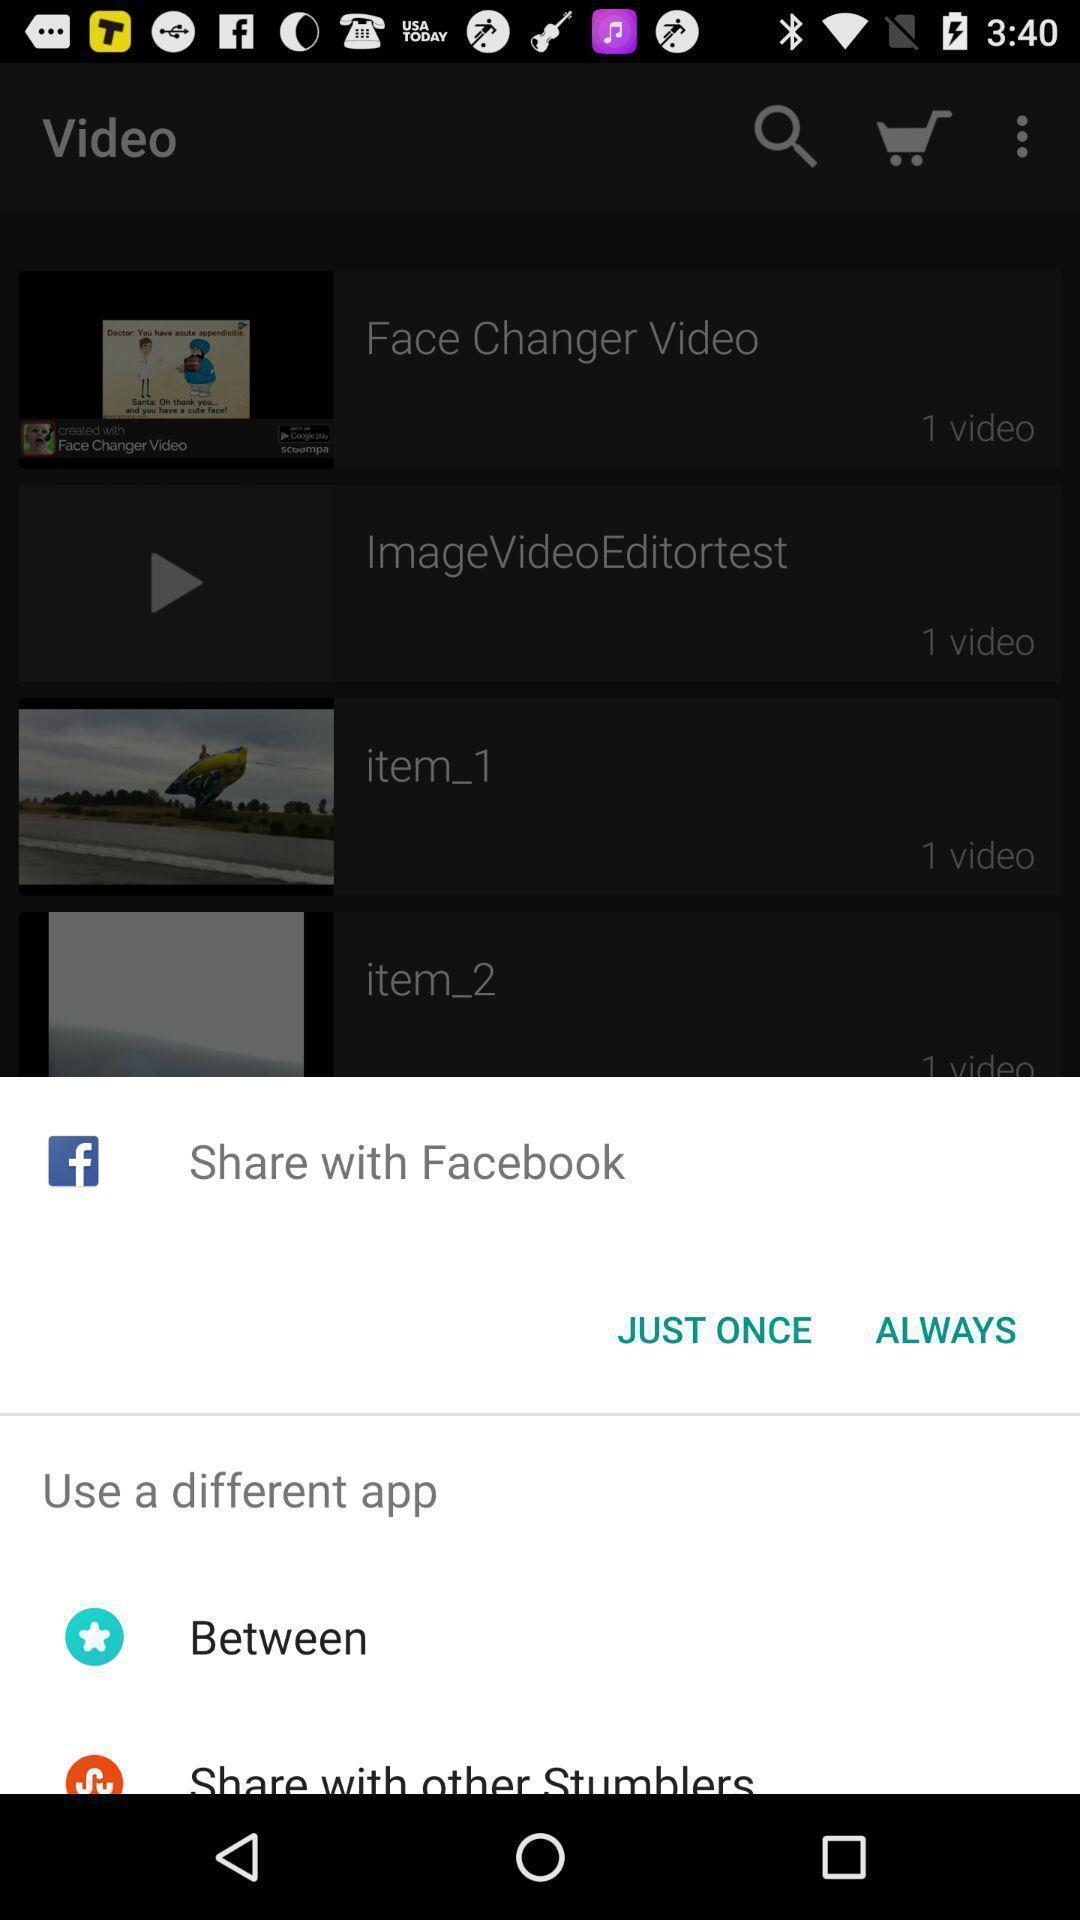Describe the visual elements of this screenshot. Pop-up showing video sharing options. 